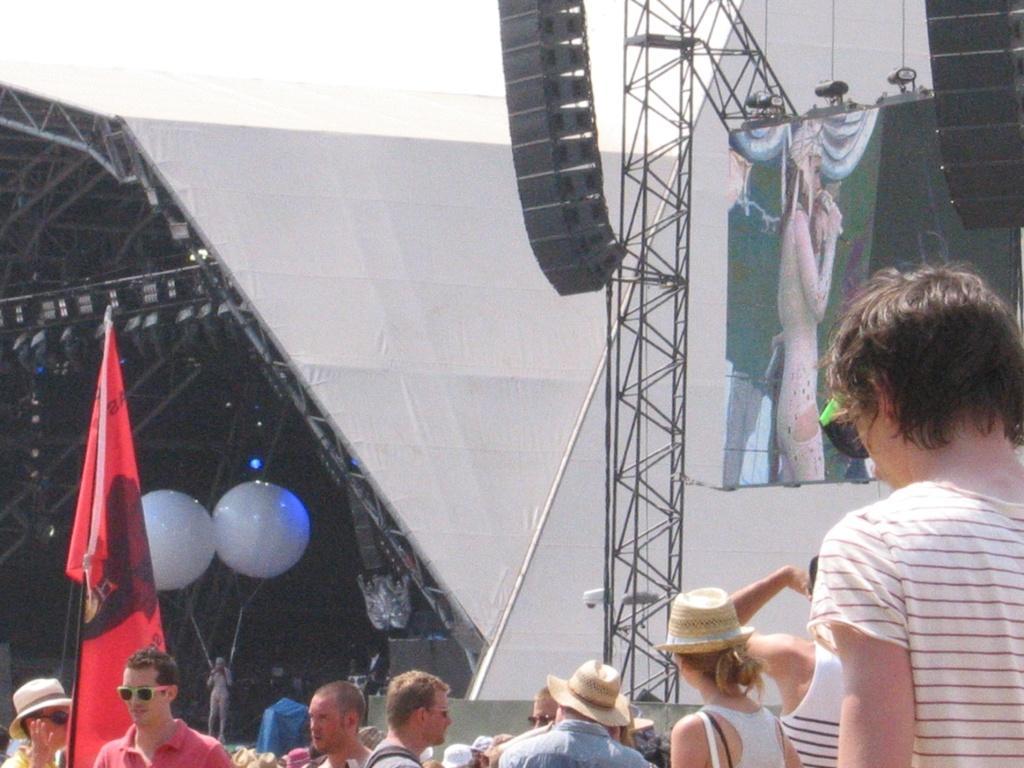Could you give a brief overview of what you see in this image? In this picture we can see a group of people were some of them wore goggles and caps, flags, rods, balloons, screen, lights and some objects. 